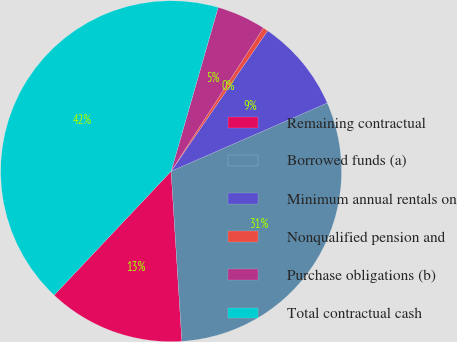Convert chart. <chart><loc_0><loc_0><loc_500><loc_500><pie_chart><fcel>Remaining contractual<fcel>Borrowed funds (a)<fcel>Minimum annual rentals on<fcel>Nonqualified pension and<fcel>Purchase obligations (b)<fcel>Total contractual cash<nl><fcel>13.05%<fcel>30.55%<fcel>8.86%<fcel>0.47%<fcel>4.66%<fcel>42.41%<nl></chart> 